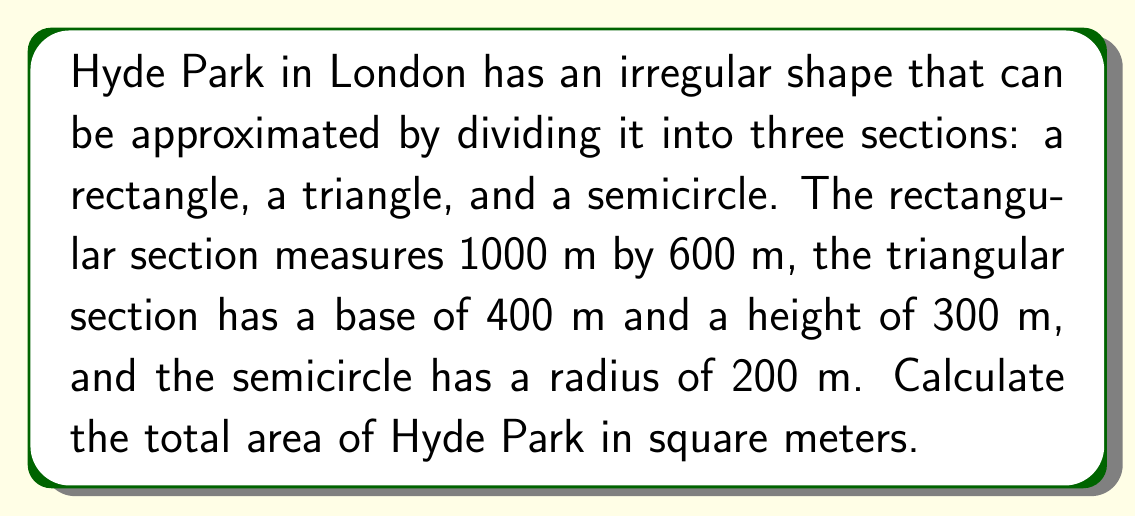What is the answer to this math problem? To calculate the total area of Hyde Park, we need to sum the areas of the three sections:

1. Rectangle area:
   $$A_r = l \times w = 1000 \text{ m} \times 600 \text{ m} = 600,000 \text{ m}^2$$

2. Triangle area:
   $$A_t = \frac{1}{2} \times b \times h = \frac{1}{2} \times 400 \text{ m} \times 300 \text{ m} = 60,000 \text{ m}^2$$

3. Semicircle area:
   $$A_s = \frac{1}{2} \times \pi r^2 = \frac{1}{2} \times \pi \times (200 \text{ m})^2 = 62,831.85 \text{ m}^2$$

Total area:
$$A_{\text{total}} = A_r + A_t + A_s = 600,000 + 60,000 + 62,831.85 = 722,831.85 \text{ m}^2$$

[asy]
import geometry;

size(200);
fill(box((0,0),(10,6)), lightgray);
fill(polygon((10,0),(14,0),(10,3)), lightgray);
fill(arc((10,6),2,270,90), lightgray);

draw(box((0,0),(10,6)));
draw((10,0)--(14,0)--(10,3)--cycle);
draw(arc((10,6),2,270,90));

label("1000 m", (5,0), S);
label("600 m", (0,3), W);
label("400 m", (12,0), S);
label("300 m", (11,1.5), E);
label("r = 200 m", (11,6), NE);
[/asy]
Answer: 722,831.85 m² 